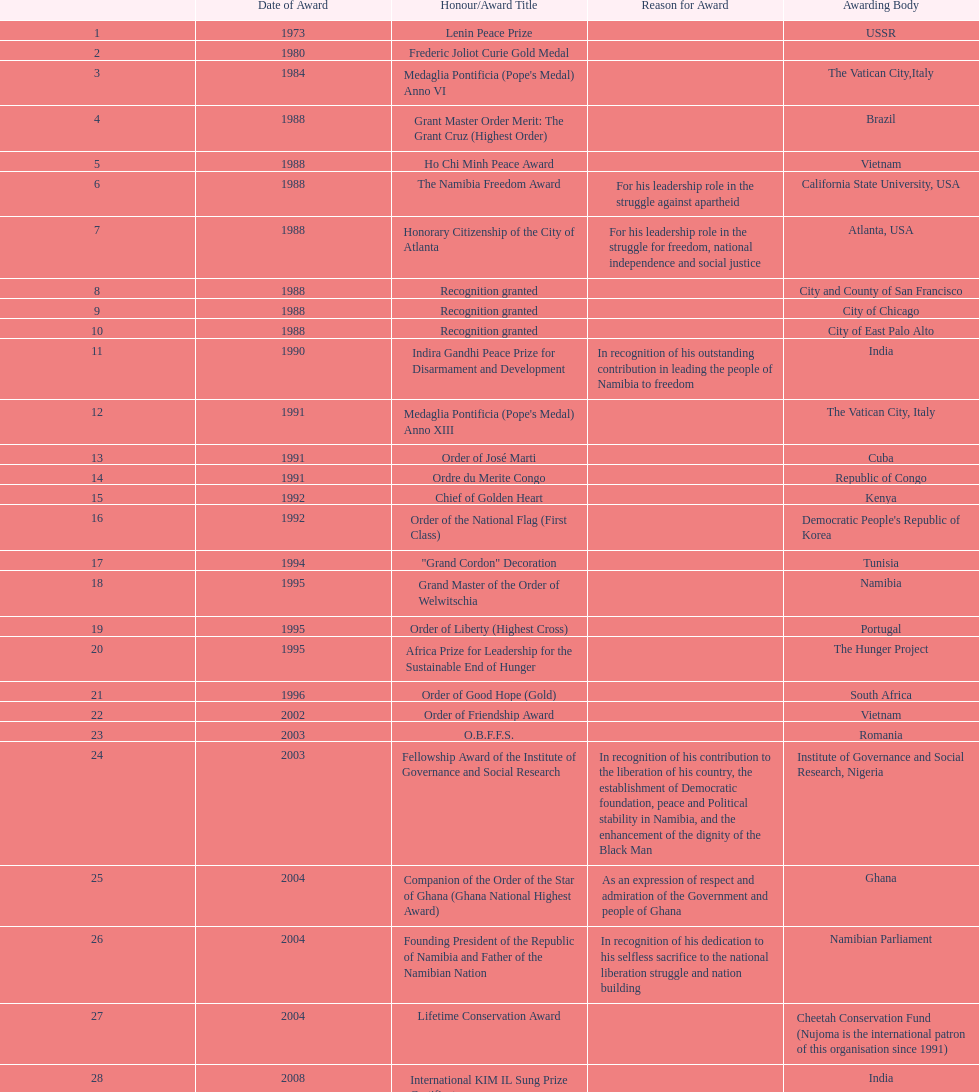What is the latest award nujoma has been honored with? Sir Seretse Khama SADC Meda. 